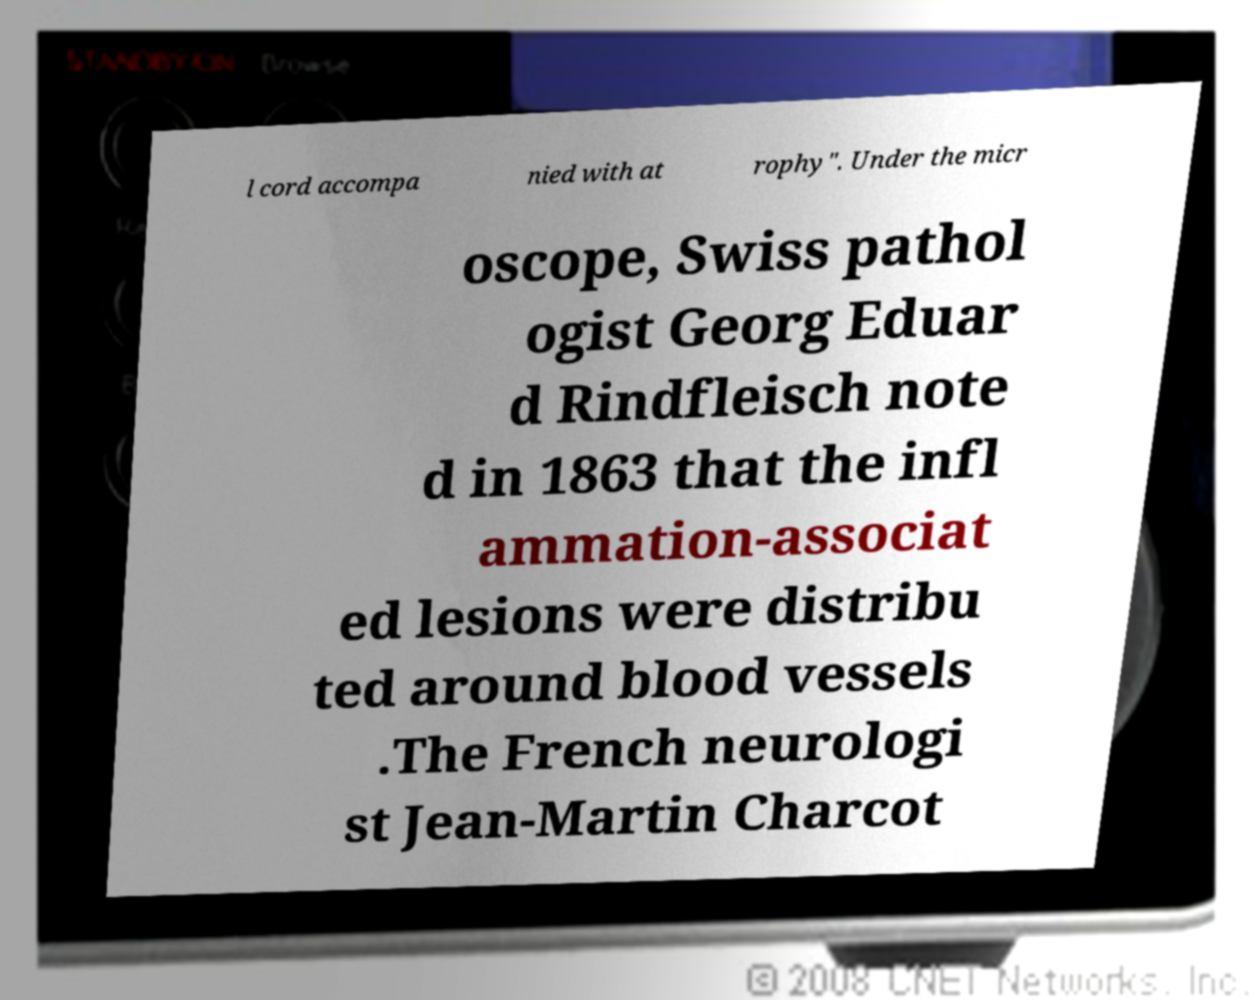Could you assist in decoding the text presented in this image and type it out clearly? l cord accompa nied with at rophy". Under the micr oscope, Swiss pathol ogist Georg Eduar d Rindfleisch note d in 1863 that the infl ammation-associat ed lesions were distribu ted around blood vessels .The French neurologi st Jean-Martin Charcot 